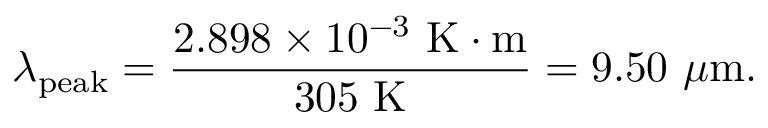Convert formula to latex. <formula><loc_0><loc_0><loc_500><loc_500>\lambda _ { p e a k } = { \frac { 2 . 8 9 8 \times 1 0 ^ { - 3 } { K } \cdot { m } } { 3 0 5 { K } } } = 9 . 5 0 \mu { m } .</formula> 